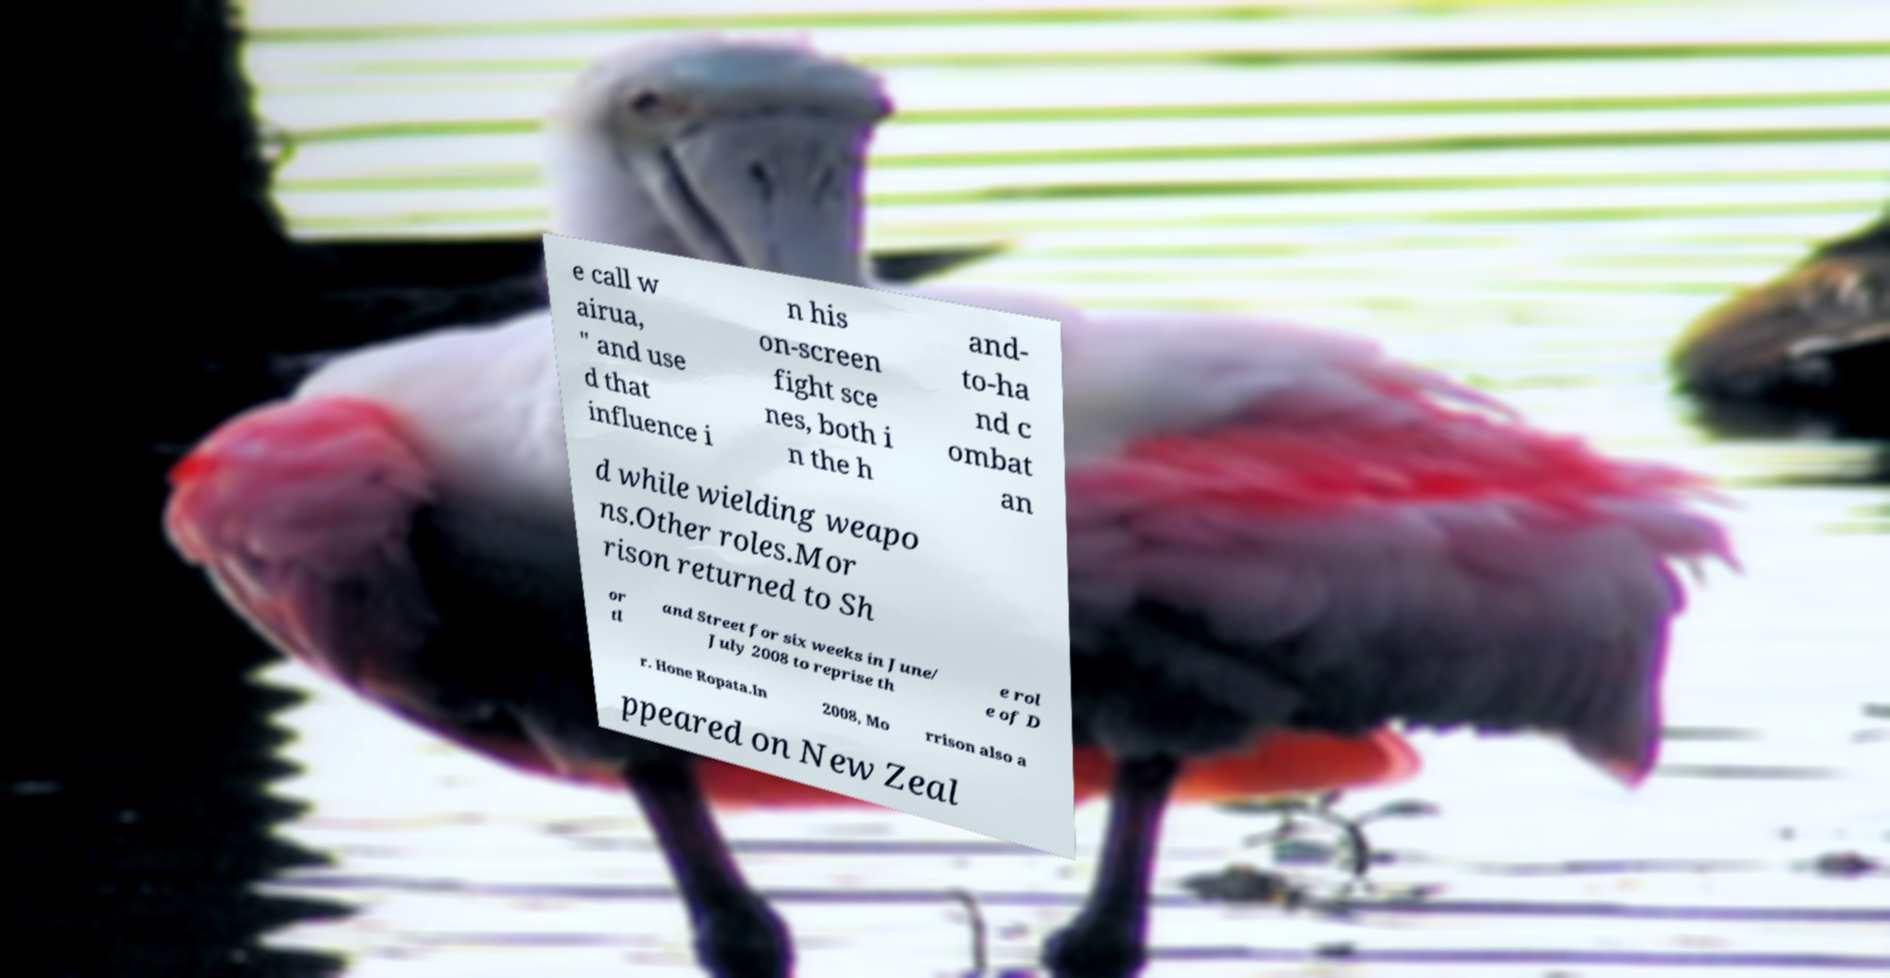I need the written content from this picture converted into text. Can you do that? e call w airua, " and use d that influence i n his on-screen fight sce nes, both i n the h and- to-ha nd c ombat an d while wielding weapo ns.Other roles.Mor rison returned to Sh or tl and Street for six weeks in June/ July 2008 to reprise th e rol e of D r. Hone Ropata.In 2008, Mo rrison also a ppeared on New Zeal 